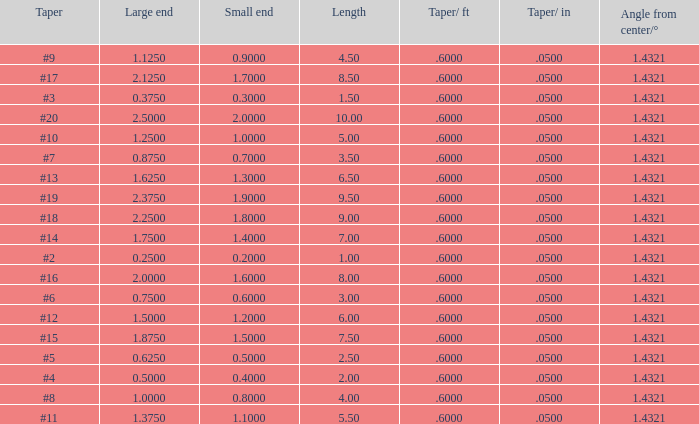5, and a taper of #2? 0.6. 